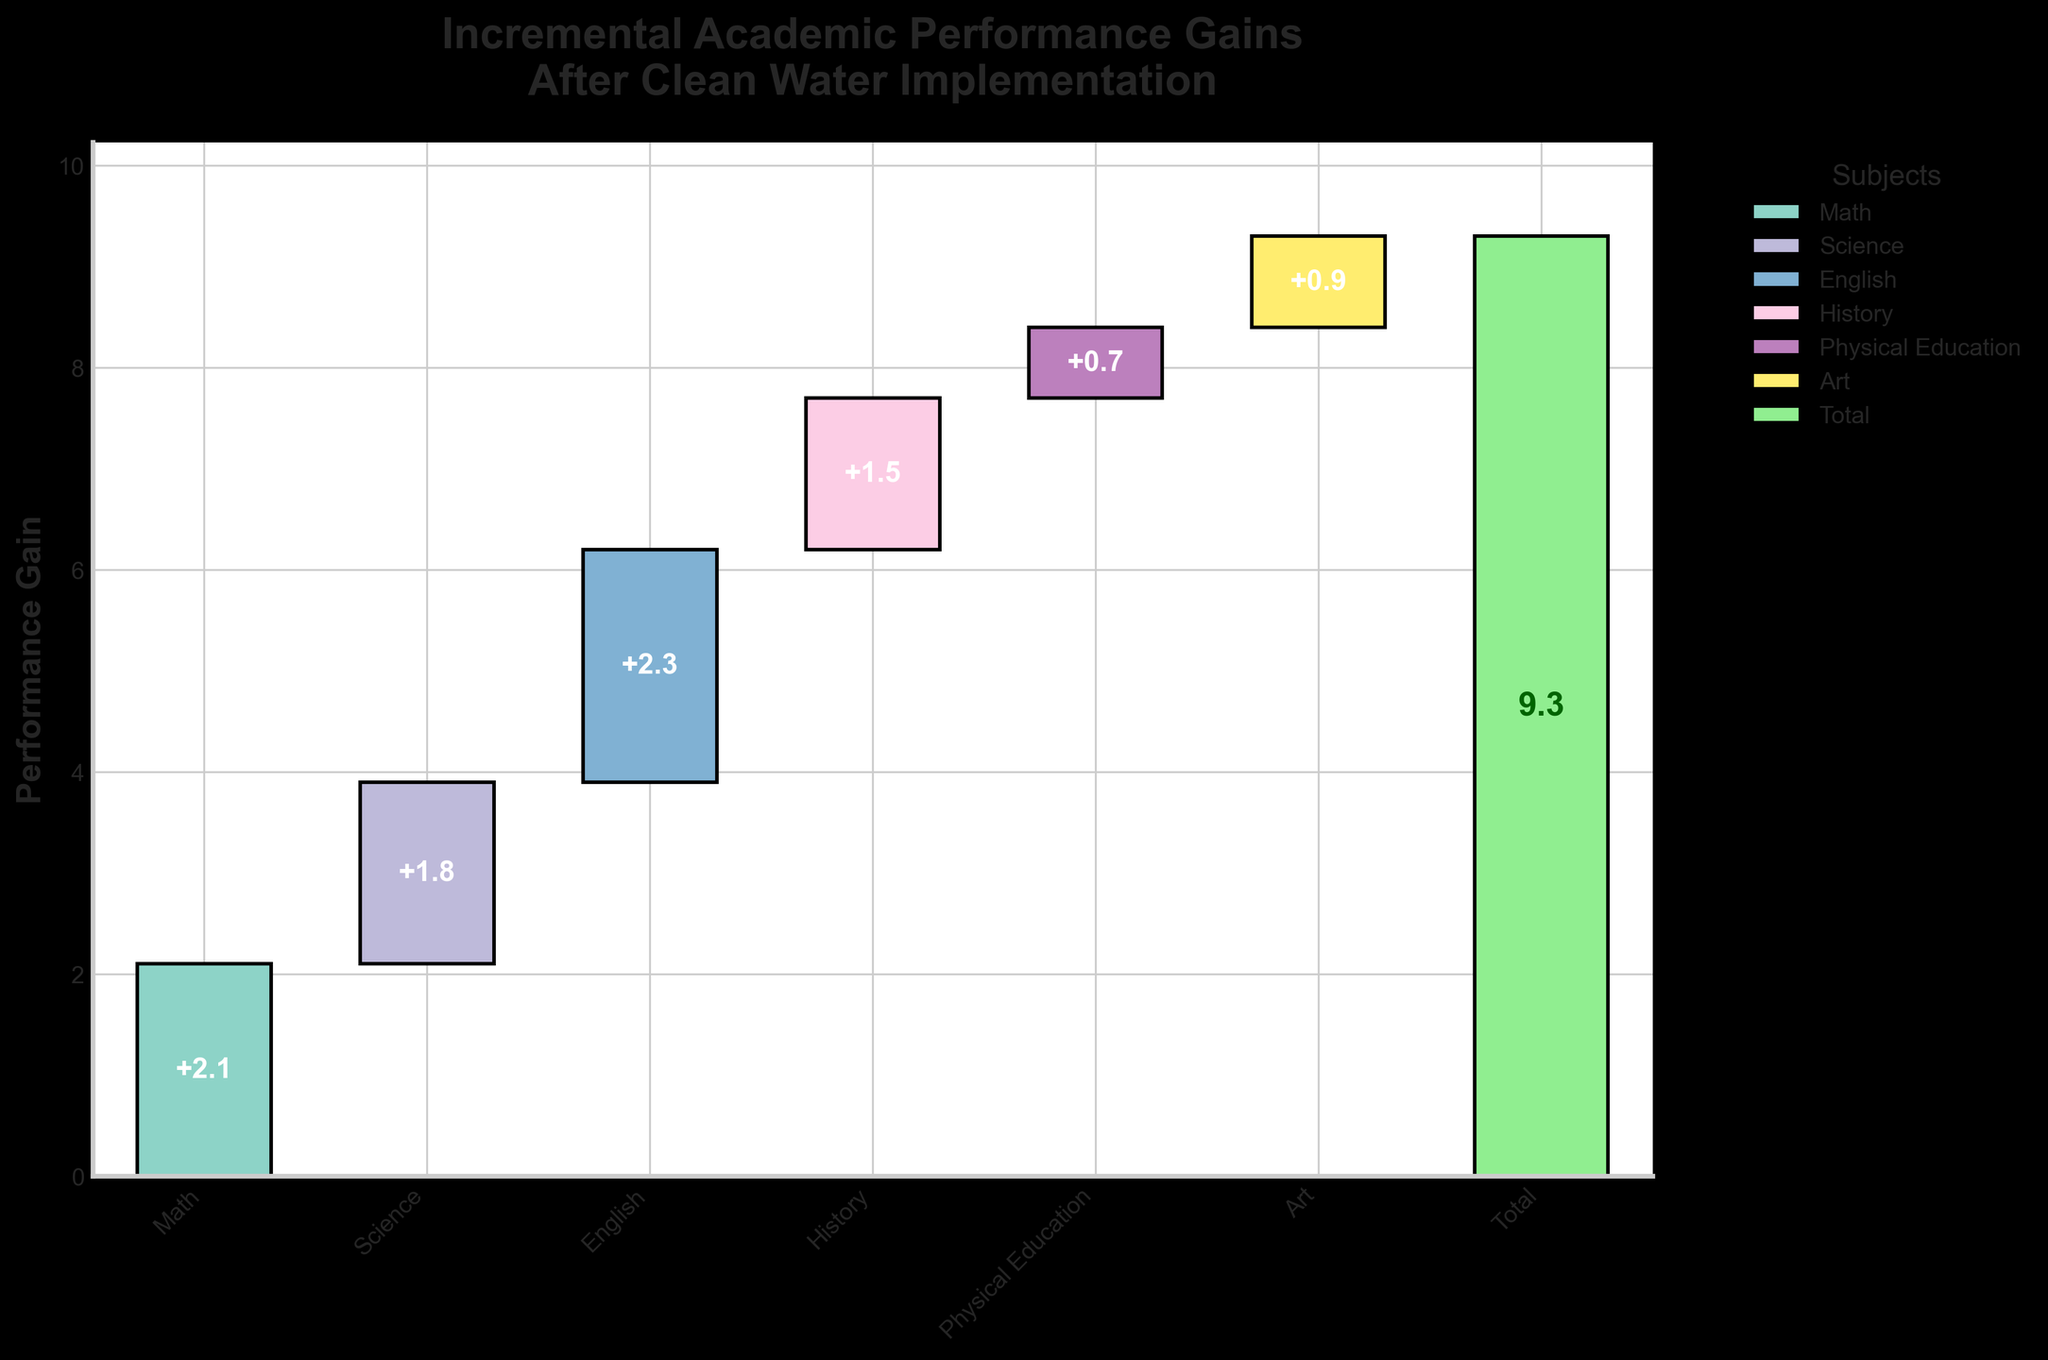How many subjects are shown in the figure? The plot shows individual bars for each subject that have observed performance gains. Each bar corresponds to one subject. Counting the bars, we can see there are six subjects shown.
Answer: 6 What is the total incremental performance gain after clean water implementation? The last bar in the plot represents the 'Total' performance gain. The value displayed in the bar is 9.3, which is the sum of all individual gains.
Answer: 9.3 Which subject had the highest performance gain? By comparing the heights of the individual bars, the bar for 'English' is the tallest. The label inside the bar confirms this as 2.3, which is the highest gain.
Answer: English What is the cumulative performance gain of Math and Science? The performance gains of Math and Science are 2.1 and 1.8, respectively. By adding these two values together, we get 2.1 + 1.8 = 3.9.
Answer: 3.9 Which had a greater performance gain, History or Physical Education? By comparing the heights of the bars, the History bar is higher than the Physical Education bar. History has a gain of 1.5, whereas Physical Education has a gain of 0.7.
Answer: History How does the Art performance gain compare to other subjects? The Art subject has a performance gain of 0.9. Compared to other subjects, it is higher than Physical Education (0.7) but lower than Math (2.1), Science (1.8), English (2.3), and History (1.5).
Answer: Lower than most What is the average performance gain per subject? There are six subjects and a total gain of 9.3. Dividing the total gain by the number of subjects gives us 9.3 / 6 = 1.55.
Answer: 1.55 What is the least incremental gain observed, and in which subject? Examining the heights of the bars, Physical Education has the shortest bar. The label shows the gain as 0.7, which is the least observed gain.
Answer: Physical Education What is the combined performance gain for subjects with more than 1.5 gain? Subjects with more than 1.5 gain are Math (2.1), Science (1.8), and English (2.3). Adding these values together, we get 2.1 + 1.8 + 2.3 = 6.2.
Answer: 6.2 